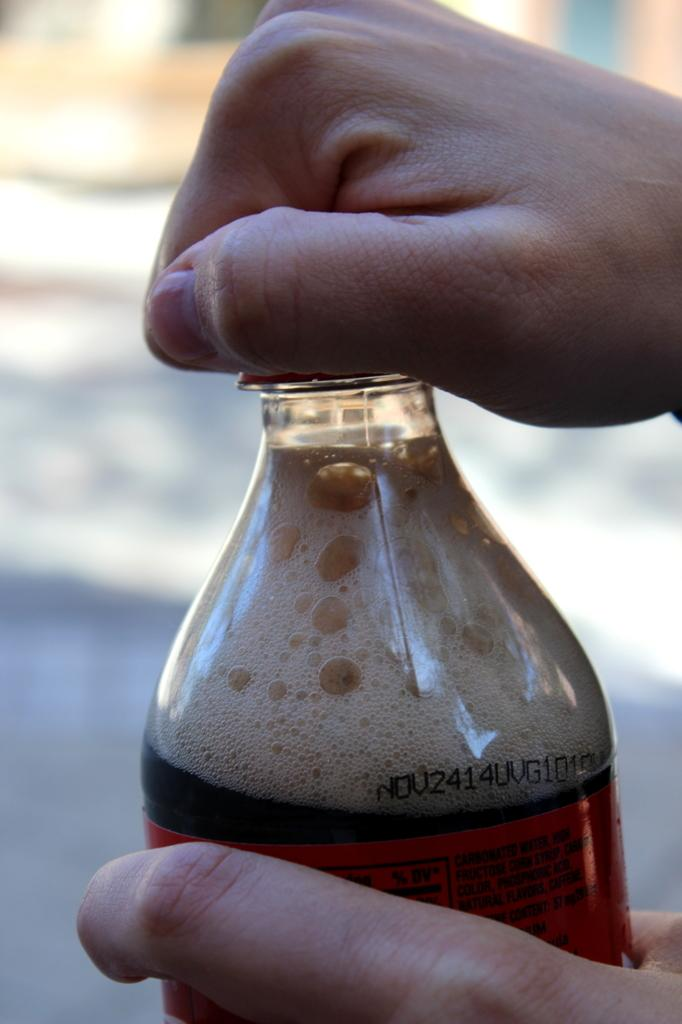Who is in the image? There is a person in the image. What is the person doing in the image? The person is opening a bottle cap. What is inside the bottle that the person is opening? The bottle contains a drink. Can you see any snails or mountains in the image? No, there are no snails or mountains present in the image. 